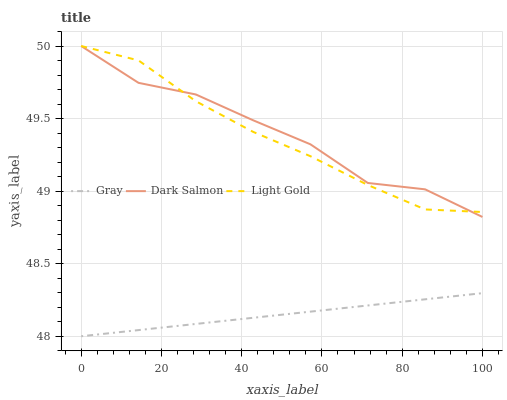Does Light Gold have the minimum area under the curve?
Answer yes or no. No. Does Light Gold have the maximum area under the curve?
Answer yes or no. No. Is Light Gold the smoothest?
Answer yes or no. No. Is Light Gold the roughest?
Answer yes or no. No. Does Dark Salmon have the lowest value?
Answer yes or no. No. Is Gray less than Light Gold?
Answer yes or no. Yes. Is Dark Salmon greater than Gray?
Answer yes or no. Yes. Does Gray intersect Light Gold?
Answer yes or no. No. 